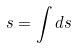<formula> <loc_0><loc_0><loc_500><loc_500>s = \int d s</formula> 